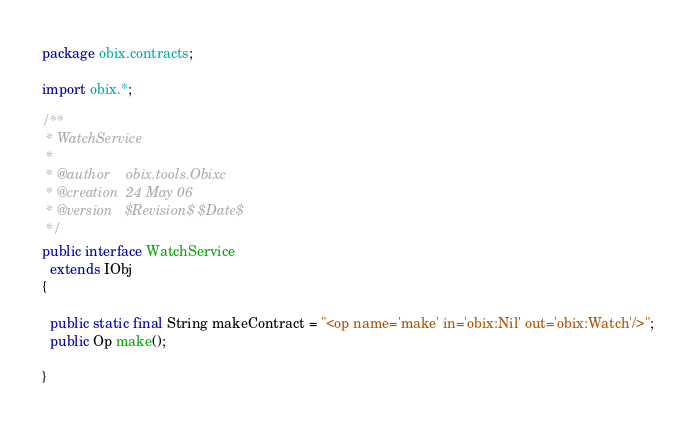<code> <loc_0><loc_0><loc_500><loc_500><_Java_>package obix.contracts;

import obix.*;

/**
 * WatchService
 *
 * @author    obix.tools.Obixc
 * @creation  24 May 06
 * @version   $Revision$ $Date$
 */
public interface WatchService
  extends IObj
{

  public static final String makeContract = "<op name='make' in='obix:Nil' out='obix:Watch'/>";
  public Op make();

}
</code> 